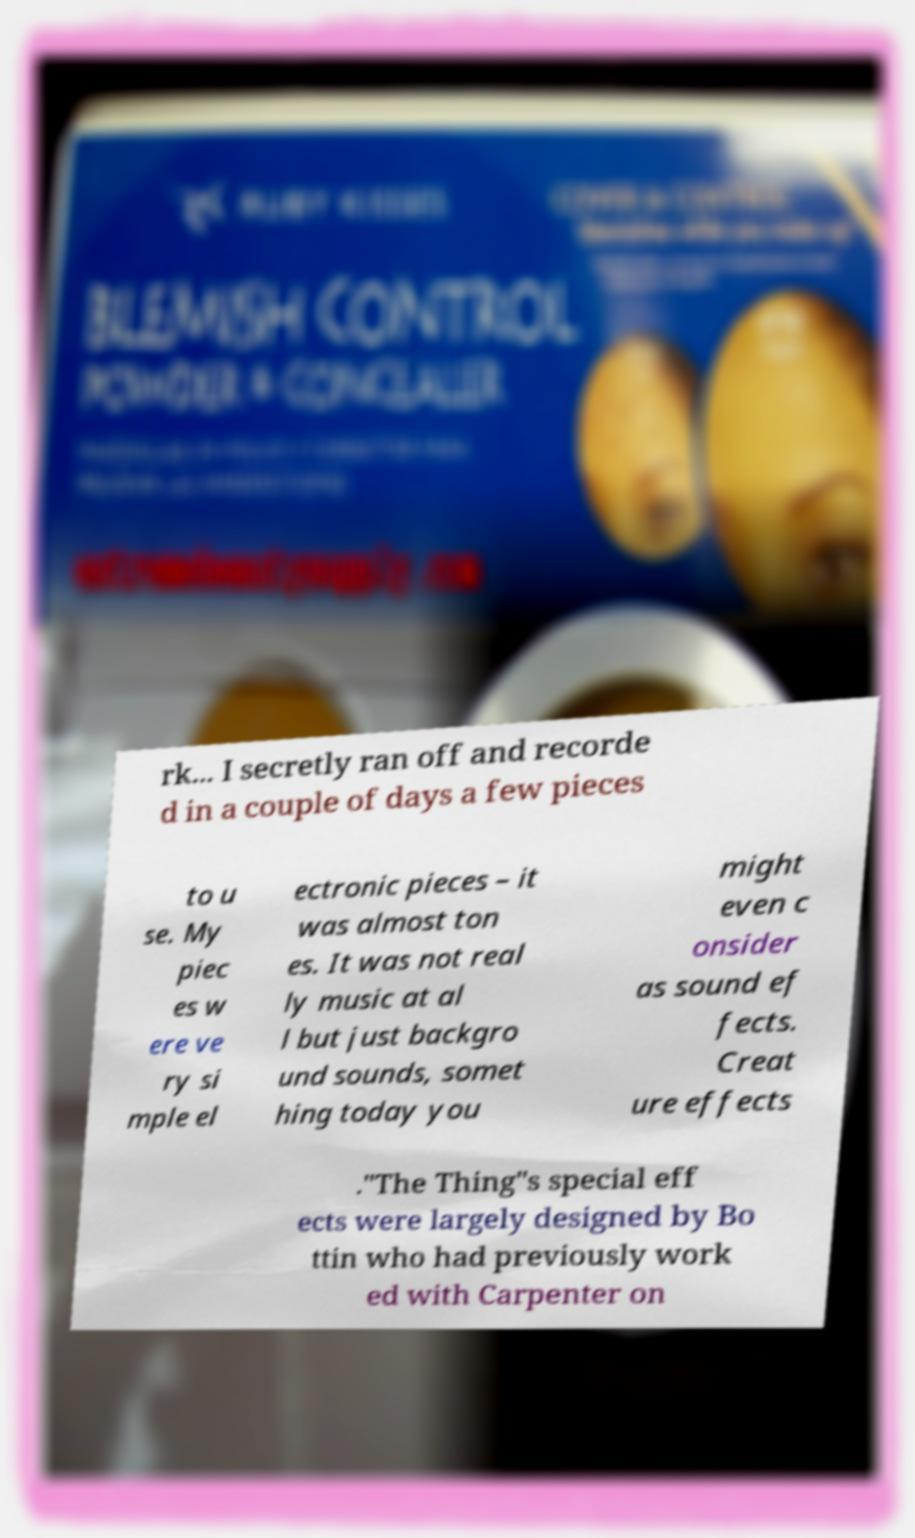I need the written content from this picture converted into text. Can you do that? rk... I secretly ran off and recorde d in a couple of days a few pieces to u se. My piec es w ere ve ry si mple el ectronic pieces – it was almost ton es. It was not real ly music at al l but just backgro und sounds, somet hing today you might even c onsider as sound ef fects. Creat ure effects ."The Thing"s special eff ects were largely designed by Bo ttin who had previously work ed with Carpenter on 